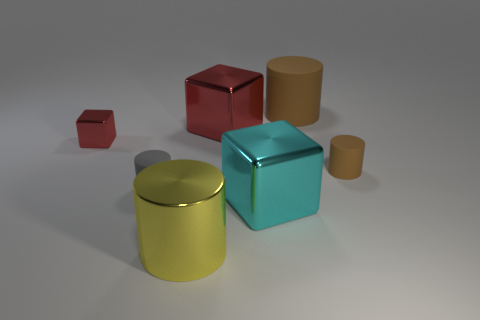Subtract all big brown matte cylinders. How many cylinders are left? 3 Subtract all cubes. How many objects are left? 4 Add 1 small cylinders. How many objects exist? 8 Subtract 0 green cylinders. How many objects are left? 7 Subtract 2 cylinders. How many cylinders are left? 2 Subtract all red blocks. Subtract all gray balls. How many blocks are left? 1 Subtract all purple cylinders. How many blue blocks are left? 0 Subtract all small purple rubber cylinders. Subtract all tiny gray cylinders. How many objects are left? 6 Add 2 tiny brown rubber things. How many tiny brown rubber things are left? 3 Add 5 large yellow metal things. How many large yellow metal things exist? 6 